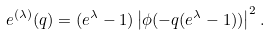<formula> <loc_0><loc_0><loc_500><loc_500>e ^ { ( \lambda ) } ( q ) = ( e ^ { \lambda } - 1 ) \left | \phi ( - q ( e ^ { \lambda } - 1 ) ) \right | ^ { 2 } .</formula> 